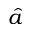<formula> <loc_0><loc_0><loc_500><loc_500>\hat { a }</formula> 